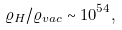Convert formula to latex. <formula><loc_0><loc_0><loc_500><loc_500>\varrho _ { H } / \varrho _ { v a c } \sim 1 0 ^ { 5 4 } ,</formula> 